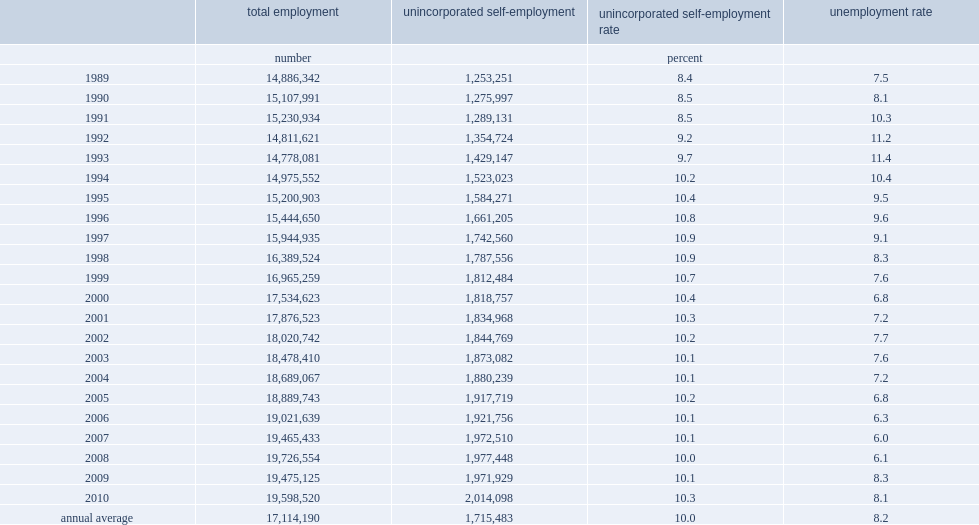What's the percent of the share of unincorporated self-employed workers in total employment from 1989 to 2010? 0.100237. What's the amount of the share of unincorporated self-employed workers in total employment. 1715483.0. What's the percent of the self-employment rate in 2003? 10.1. What's the percent of self-employment rate in 2010? 10.3. 